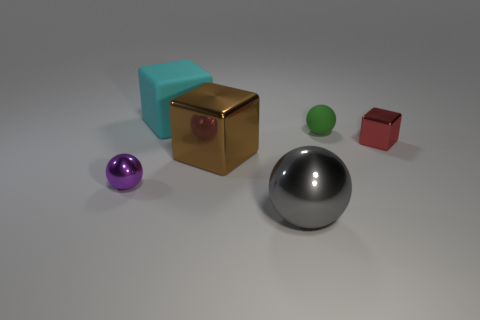What is the big cube that is in front of the cyan rubber cube made of?
Provide a short and direct response. Metal. What shape is the matte thing to the right of the metal thing that is in front of the metal ball that is behind the large gray ball?
Give a very brief answer. Sphere. Is the color of the matte block the same as the matte ball?
Make the answer very short. No. What number of other objects are the same material as the big brown thing?
Give a very brief answer. 3. What number of things are tiny green rubber balls or objects behind the gray metal ball?
Your response must be concise. 5. Are there fewer cyan matte things than small cyan balls?
Give a very brief answer. No. The large metallic object that is behind the metal ball that is right of the shiny thing that is left of the big rubber object is what color?
Provide a succinct answer. Brown. Is the tiny purple ball made of the same material as the green ball?
Ensure brevity in your answer.  No. There is a small green matte ball; how many shiny objects are in front of it?
Keep it short and to the point. 4. The gray shiny object that is the same shape as the tiny green object is what size?
Your answer should be very brief. Large. 